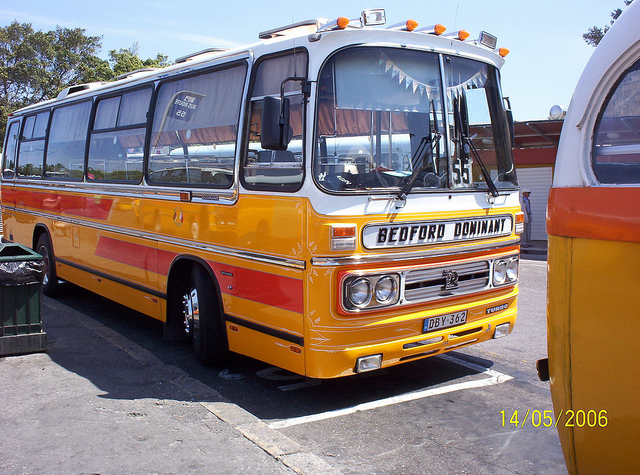Please extract the text content from this image. BEDFORD DOMINANT 55 TURBI 2006 05 14 D8Y 